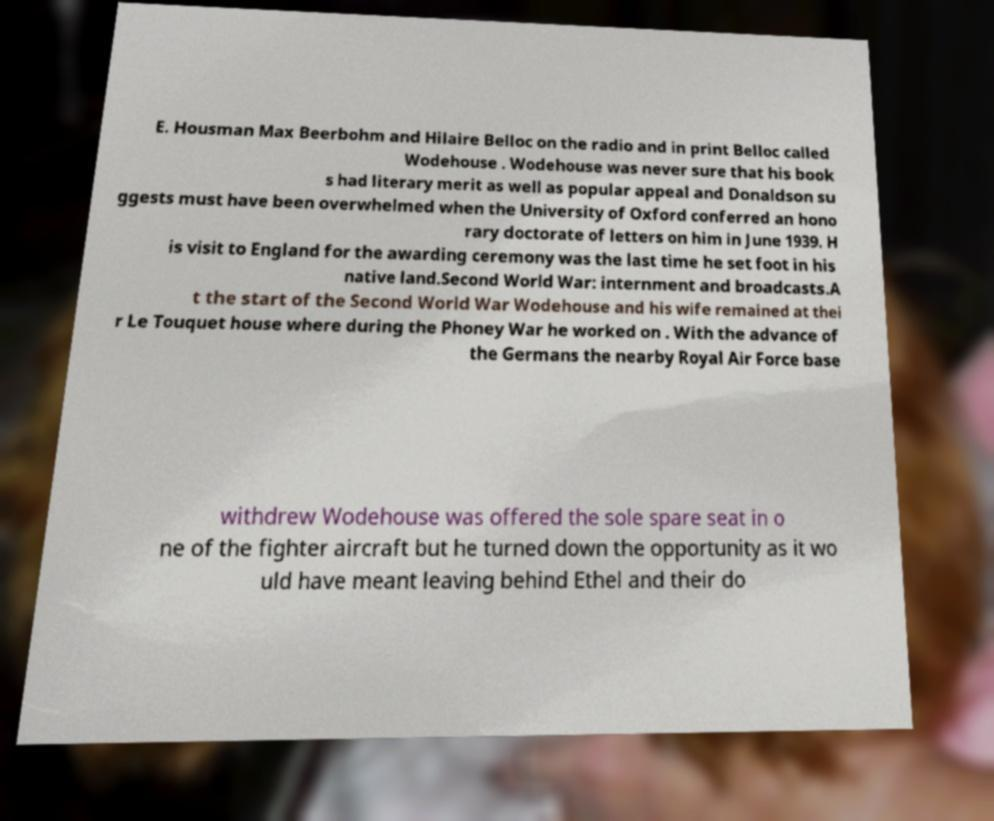For documentation purposes, I need the text within this image transcribed. Could you provide that? E. Housman Max Beerbohm and Hilaire Belloc on the radio and in print Belloc called Wodehouse . Wodehouse was never sure that his book s had literary merit as well as popular appeal and Donaldson su ggests must have been overwhelmed when the University of Oxford conferred an hono rary doctorate of letters on him in June 1939. H is visit to England for the awarding ceremony was the last time he set foot in his native land.Second World War: internment and broadcasts.A t the start of the Second World War Wodehouse and his wife remained at thei r Le Touquet house where during the Phoney War he worked on . With the advance of the Germans the nearby Royal Air Force base withdrew Wodehouse was offered the sole spare seat in o ne of the fighter aircraft but he turned down the opportunity as it wo uld have meant leaving behind Ethel and their do 